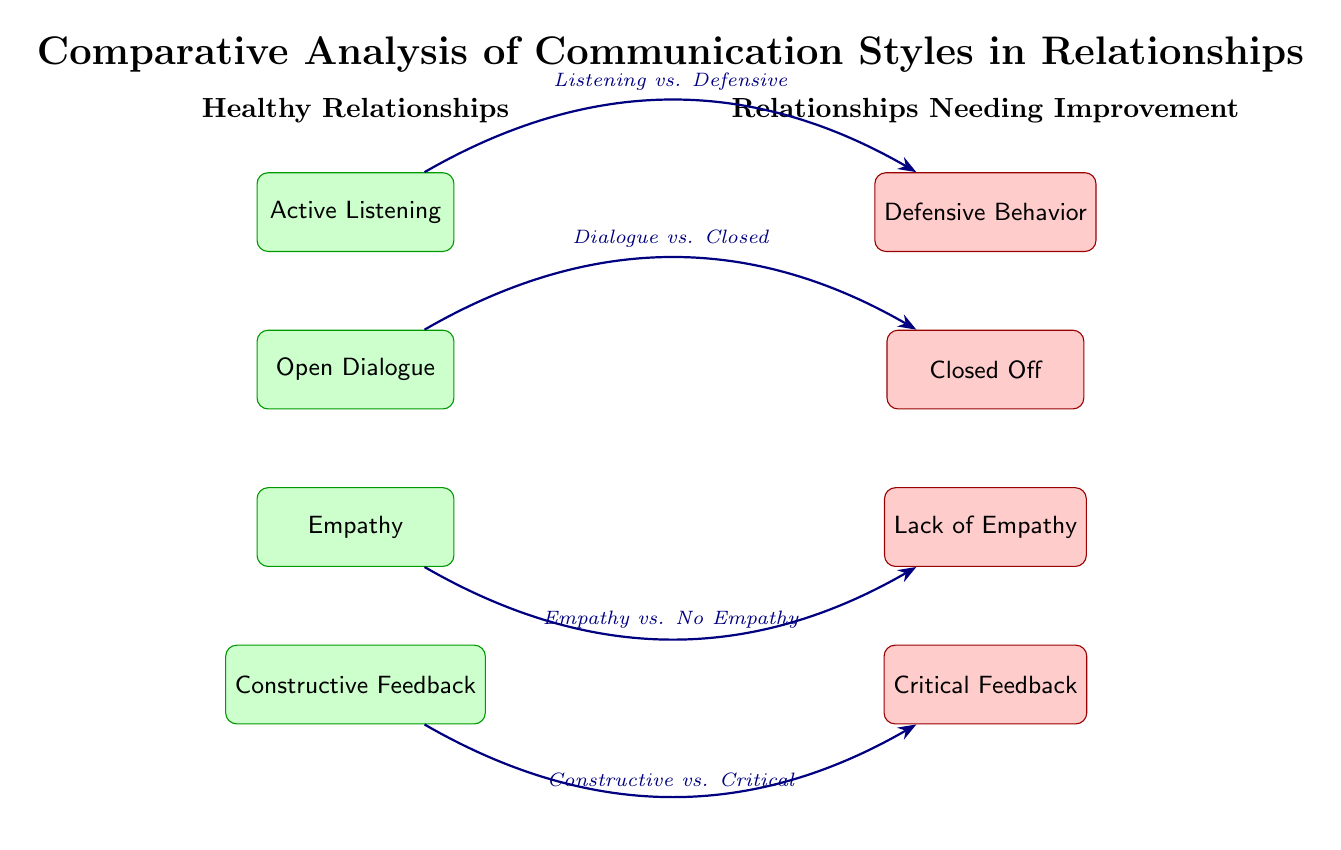What are the main types of communication styles in healthy relationships? The diagram lists four main types of communication styles in healthy relationships: Active Listening, Open Dialogue, Empathy, and Constructive Feedback. These can be found in the left section under the heading "Healthy Relationships".
Answer: Active Listening, Open Dialogue, Empathy, Constructive Feedback What are the four negative communication styles shown in relationships needing improvement? In the right section under "Relationships Needing Improvement", the diagram shows four negative communication styles: Defensive Behavior, Closed Off, Lack of Empathy, and Critical Feedback.
Answer: Defensive Behavior, Closed Off, Lack of Empathy, Critical Feedback Which style is compared to Defensive Behavior? The diagram indicates that Active Listening is compared to Defensive Behavior via a bent arrow in blue. The comparison label is "Listening vs. Defensive".
Answer: Active Listening How many total styles are listed in the diagram? There are a total of eight styles listed in the diagram: four for healthy relationships and four for relationships needing improvement. By counting these nodes, the answer can be determined.
Answer: Eight What is the relationship between Empathy and Lack of Empathy? The diagram uses a comparison edge to connect Empathy with Lack of Empathy, with the label "Empathy vs. No Empathy". This shows that the presence or absence of empathy is being contrasted.
Answer: Empathy vs. No Empathy What type of feedback is associated with Constructive Feedback? The diagram depicts that Constructive Feedback is compared to Critical Feedback, as shown by the bent blue arrow and the label "Constructive vs. Critical". This highlights the difference in feedback styles.
Answer: Critical Feedback Which two styles are directly across from each other in the diagram? In the layout of the diagram, Empathy on the left is directly across from Lack of Empathy on the right, as they are positioned at the same vertical level on opposite sides.
Answer: Empathy and Lack of Empathy What does the label between Open Dialogue and Closed Off signify? The comparison label "Dialogue vs. Closed" signifies the contrast between open communication and a guarded, closed-off approach, illustrated by the bent arrow connecting these two styles.
Answer: Dialogue vs. Closed 